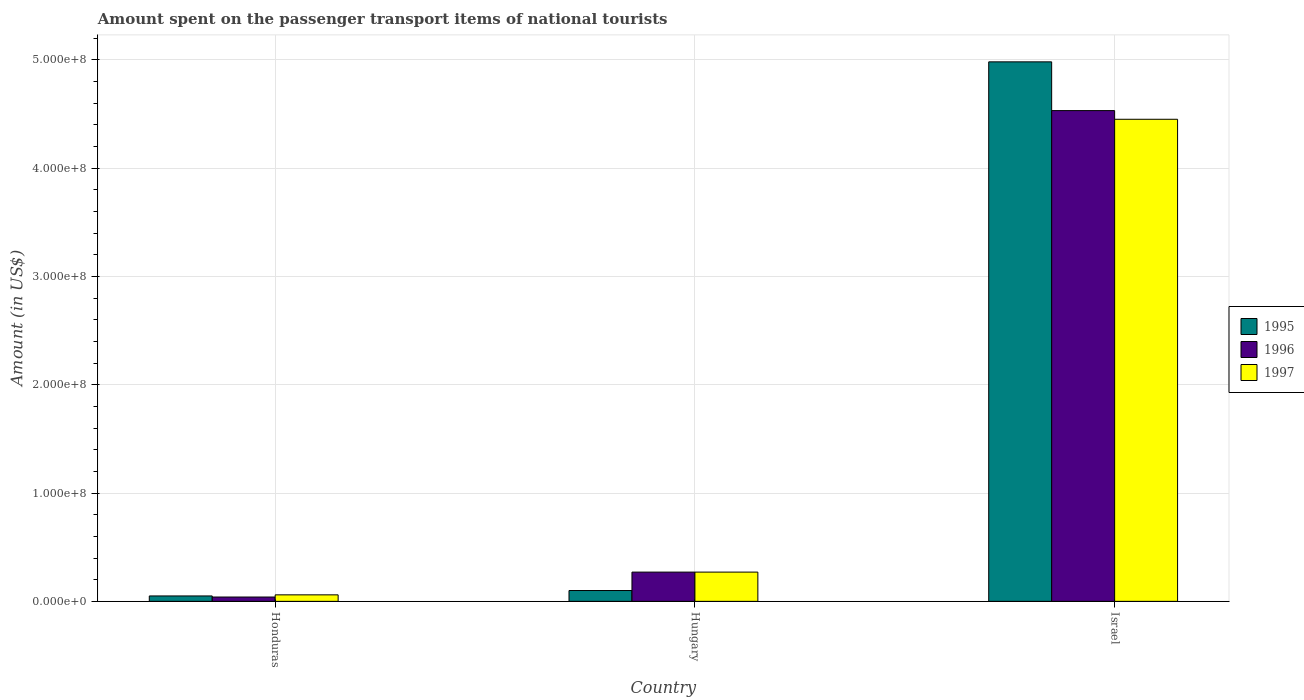Are the number of bars on each tick of the X-axis equal?
Offer a very short reply. Yes. How many bars are there on the 2nd tick from the left?
Offer a very short reply. 3. How many bars are there on the 3rd tick from the right?
Offer a very short reply. 3. What is the label of the 2nd group of bars from the left?
Provide a succinct answer. Hungary. In how many cases, is the number of bars for a given country not equal to the number of legend labels?
Make the answer very short. 0. What is the amount spent on the passenger transport items of national tourists in 1995 in Israel?
Your answer should be compact. 4.98e+08. Across all countries, what is the maximum amount spent on the passenger transport items of national tourists in 1997?
Provide a succinct answer. 4.45e+08. In which country was the amount spent on the passenger transport items of national tourists in 1996 minimum?
Your answer should be very brief. Honduras. What is the total amount spent on the passenger transport items of national tourists in 1997 in the graph?
Make the answer very short. 4.78e+08. What is the difference between the amount spent on the passenger transport items of national tourists in 1997 in Honduras and that in Israel?
Make the answer very short. -4.39e+08. What is the difference between the amount spent on the passenger transport items of national tourists in 1997 in Hungary and the amount spent on the passenger transport items of national tourists in 1995 in Honduras?
Your answer should be compact. 2.20e+07. What is the average amount spent on the passenger transport items of national tourists in 1997 per country?
Make the answer very short. 1.59e+08. In how many countries, is the amount spent on the passenger transport items of national tourists in 1997 greater than 200000000 US$?
Give a very brief answer. 1. What is the ratio of the amount spent on the passenger transport items of national tourists in 1996 in Hungary to that in Israel?
Your answer should be very brief. 0.06. Is the amount spent on the passenger transport items of national tourists in 1995 in Honduras less than that in Israel?
Your response must be concise. Yes. What is the difference between the highest and the second highest amount spent on the passenger transport items of national tourists in 1996?
Your answer should be very brief. 4.49e+08. What is the difference between the highest and the lowest amount spent on the passenger transport items of national tourists in 1995?
Offer a terse response. 4.93e+08. What does the 3rd bar from the left in Hungary represents?
Offer a terse response. 1997. What does the 3rd bar from the right in Hungary represents?
Ensure brevity in your answer.  1995. Are all the bars in the graph horizontal?
Offer a very short reply. No. How many countries are there in the graph?
Ensure brevity in your answer.  3. What is the difference between two consecutive major ticks on the Y-axis?
Your answer should be very brief. 1.00e+08. Are the values on the major ticks of Y-axis written in scientific E-notation?
Give a very brief answer. Yes. Does the graph contain grids?
Offer a very short reply. Yes. Where does the legend appear in the graph?
Offer a very short reply. Center right. How are the legend labels stacked?
Your response must be concise. Vertical. What is the title of the graph?
Your answer should be compact. Amount spent on the passenger transport items of national tourists. What is the Amount (in US$) in 1995 in Honduras?
Keep it short and to the point. 5.00e+06. What is the Amount (in US$) of 1997 in Honduras?
Keep it short and to the point. 6.00e+06. What is the Amount (in US$) in 1996 in Hungary?
Keep it short and to the point. 2.70e+07. What is the Amount (in US$) of 1997 in Hungary?
Offer a terse response. 2.70e+07. What is the Amount (in US$) of 1995 in Israel?
Offer a terse response. 4.98e+08. What is the Amount (in US$) in 1996 in Israel?
Keep it short and to the point. 4.53e+08. What is the Amount (in US$) of 1997 in Israel?
Provide a succinct answer. 4.45e+08. Across all countries, what is the maximum Amount (in US$) of 1995?
Provide a short and direct response. 4.98e+08. Across all countries, what is the maximum Amount (in US$) of 1996?
Your answer should be very brief. 4.53e+08. Across all countries, what is the maximum Amount (in US$) of 1997?
Your answer should be very brief. 4.45e+08. Across all countries, what is the minimum Amount (in US$) in 1995?
Ensure brevity in your answer.  5.00e+06. Across all countries, what is the minimum Amount (in US$) of 1996?
Your answer should be compact. 4.00e+06. What is the total Amount (in US$) in 1995 in the graph?
Your answer should be very brief. 5.13e+08. What is the total Amount (in US$) in 1996 in the graph?
Your answer should be very brief. 4.84e+08. What is the total Amount (in US$) in 1997 in the graph?
Your answer should be compact. 4.78e+08. What is the difference between the Amount (in US$) of 1995 in Honduras and that in Hungary?
Keep it short and to the point. -5.00e+06. What is the difference between the Amount (in US$) of 1996 in Honduras and that in Hungary?
Provide a succinct answer. -2.30e+07. What is the difference between the Amount (in US$) of 1997 in Honduras and that in Hungary?
Give a very brief answer. -2.10e+07. What is the difference between the Amount (in US$) of 1995 in Honduras and that in Israel?
Provide a short and direct response. -4.93e+08. What is the difference between the Amount (in US$) in 1996 in Honduras and that in Israel?
Offer a terse response. -4.49e+08. What is the difference between the Amount (in US$) of 1997 in Honduras and that in Israel?
Offer a terse response. -4.39e+08. What is the difference between the Amount (in US$) of 1995 in Hungary and that in Israel?
Provide a short and direct response. -4.88e+08. What is the difference between the Amount (in US$) in 1996 in Hungary and that in Israel?
Give a very brief answer. -4.26e+08. What is the difference between the Amount (in US$) of 1997 in Hungary and that in Israel?
Ensure brevity in your answer.  -4.18e+08. What is the difference between the Amount (in US$) of 1995 in Honduras and the Amount (in US$) of 1996 in Hungary?
Offer a terse response. -2.20e+07. What is the difference between the Amount (in US$) of 1995 in Honduras and the Amount (in US$) of 1997 in Hungary?
Provide a short and direct response. -2.20e+07. What is the difference between the Amount (in US$) of 1996 in Honduras and the Amount (in US$) of 1997 in Hungary?
Keep it short and to the point. -2.30e+07. What is the difference between the Amount (in US$) of 1995 in Honduras and the Amount (in US$) of 1996 in Israel?
Make the answer very short. -4.48e+08. What is the difference between the Amount (in US$) in 1995 in Honduras and the Amount (in US$) in 1997 in Israel?
Keep it short and to the point. -4.40e+08. What is the difference between the Amount (in US$) in 1996 in Honduras and the Amount (in US$) in 1997 in Israel?
Offer a very short reply. -4.41e+08. What is the difference between the Amount (in US$) in 1995 in Hungary and the Amount (in US$) in 1996 in Israel?
Ensure brevity in your answer.  -4.43e+08. What is the difference between the Amount (in US$) in 1995 in Hungary and the Amount (in US$) in 1997 in Israel?
Your response must be concise. -4.35e+08. What is the difference between the Amount (in US$) in 1996 in Hungary and the Amount (in US$) in 1997 in Israel?
Give a very brief answer. -4.18e+08. What is the average Amount (in US$) in 1995 per country?
Ensure brevity in your answer.  1.71e+08. What is the average Amount (in US$) of 1996 per country?
Provide a short and direct response. 1.61e+08. What is the average Amount (in US$) in 1997 per country?
Offer a very short reply. 1.59e+08. What is the difference between the Amount (in US$) in 1995 and Amount (in US$) in 1997 in Honduras?
Offer a very short reply. -1.00e+06. What is the difference between the Amount (in US$) of 1995 and Amount (in US$) of 1996 in Hungary?
Your response must be concise. -1.70e+07. What is the difference between the Amount (in US$) in 1995 and Amount (in US$) in 1997 in Hungary?
Offer a terse response. -1.70e+07. What is the difference between the Amount (in US$) in 1996 and Amount (in US$) in 1997 in Hungary?
Offer a terse response. 0. What is the difference between the Amount (in US$) of 1995 and Amount (in US$) of 1996 in Israel?
Give a very brief answer. 4.50e+07. What is the difference between the Amount (in US$) in 1995 and Amount (in US$) in 1997 in Israel?
Ensure brevity in your answer.  5.30e+07. What is the ratio of the Amount (in US$) in 1995 in Honduras to that in Hungary?
Make the answer very short. 0.5. What is the ratio of the Amount (in US$) of 1996 in Honduras to that in Hungary?
Give a very brief answer. 0.15. What is the ratio of the Amount (in US$) in 1997 in Honduras to that in Hungary?
Provide a short and direct response. 0.22. What is the ratio of the Amount (in US$) in 1995 in Honduras to that in Israel?
Provide a succinct answer. 0.01. What is the ratio of the Amount (in US$) in 1996 in Honduras to that in Israel?
Offer a terse response. 0.01. What is the ratio of the Amount (in US$) in 1997 in Honduras to that in Israel?
Provide a succinct answer. 0.01. What is the ratio of the Amount (in US$) of 1995 in Hungary to that in Israel?
Give a very brief answer. 0.02. What is the ratio of the Amount (in US$) in 1996 in Hungary to that in Israel?
Keep it short and to the point. 0.06. What is the ratio of the Amount (in US$) of 1997 in Hungary to that in Israel?
Provide a short and direct response. 0.06. What is the difference between the highest and the second highest Amount (in US$) of 1995?
Your answer should be very brief. 4.88e+08. What is the difference between the highest and the second highest Amount (in US$) of 1996?
Your answer should be very brief. 4.26e+08. What is the difference between the highest and the second highest Amount (in US$) of 1997?
Your response must be concise. 4.18e+08. What is the difference between the highest and the lowest Amount (in US$) in 1995?
Provide a succinct answer. 4.93e+08. What is the difference between the highest and the lowest Amount (in US$) in 1996?
Make the answer very short. 4.49e+08. What is the difference between the highest and the lowest Amount (in US$) of 1997?
Your answer should be very brief. 4.39e+08. 